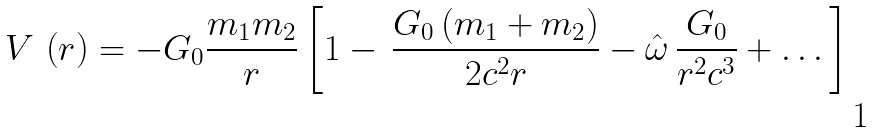<formula> <loc_0><loc_0><loc_500><loc_500>V \, \left ( r \right ) = - G _ { 0 } \frac { m _ { 1 } m _ { 2 } } { r } \left [ 1 - \, \frac { G _ { 0 } \left ( m _ { 1 } + m _ { 2 } \right ) } { 2 c ^ { 2 } r } - \hat { \omega } \, \frac { G _ { 0 } } { r ^ { 2 } c ^ { 3 } } + \dots \right ]</formula> 